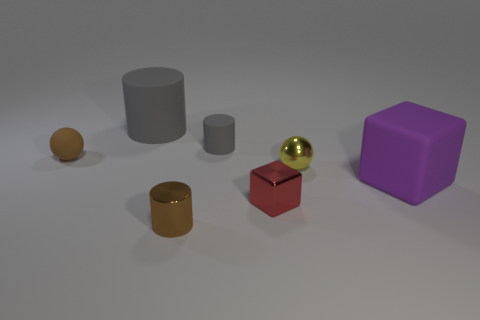Add 1 brown things. How many objects exist? 8 Subtract all tiny gray cylinders. How many cylinders are left? 2 Subtract 1 spheres. How many spheres are left? 1 Subtract all cubes. How many objects are left? 5 Subtract all red blocks. How many blocks are left? 1 Subtract all yellow cylinders. Subtract all yellow spheres. How many cylinders are left? 3 Subtract all blue cubes. How many red cylinders are left? 0 Subtract all rubber cylinders. Subtract all small metal blocks. How many objects are left? 4 Add 1 large purple matte objects. How many large purple matte objects are left? 2 Add 6 tiny red metal things. How many tiny red metal things exist? 7 